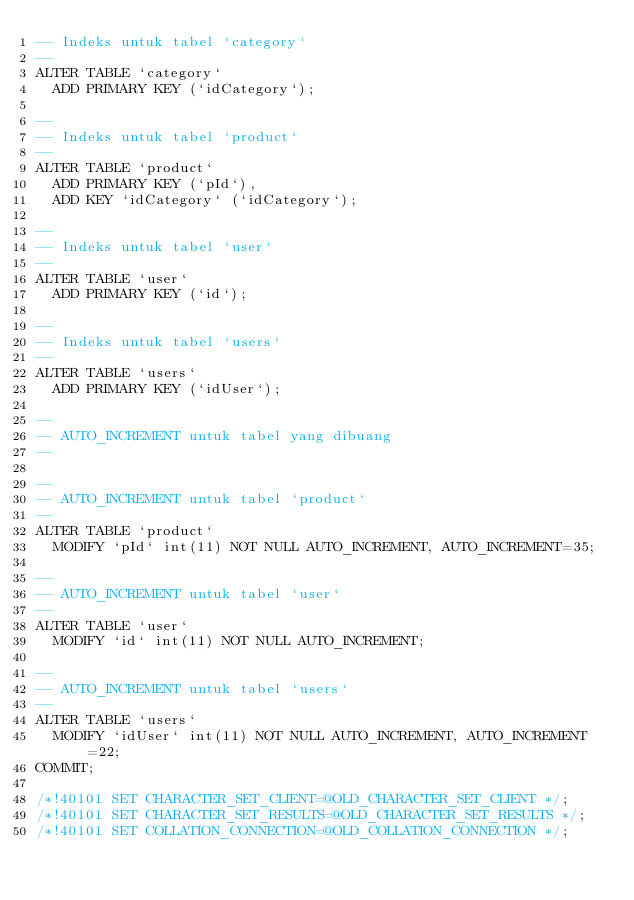Convert code to text. <code><loc_0><loc_0><loc_500><loc_500><_SQL_>-- Indeks untuk tabel `category`
--
ALTER TABLE `category`
  ADD PRIMARY KEY (`idCategory`);

--
-- Indeks untuk tabel `product`
--
ALTER TABLE `product`
  ADD PRIMARY KEY (`pId`),
  ADD KEY `idCategory` (`idCategory`);

--
-- Indeks untuk tabel `user`
--
ALTER TABLE `user`
  ADD PRIMARY KEY (`id`);

--
-- Indeks untuk tabel `users`
--
ALTER TABLE `users`
  ADD PRIMARY KEY (`idUser`);

--
-- AUTO_INCREMENT untuk tabel yang dibuang
--

--
-- AUTO_INCREMENT untuk tabel `product`
--
ALTER TABLE `product`
  MODIFY `pId` int(11) NOT NULL AUTO_INCREMENT, AUTO_INCREMENT=35;

--
-- AUTO_INCREMENT untuk tabel `user`
--
ALTER TABLE `user`
  MODIFY `id` int(11) NOT NULL AUTO_INCREMENT;

--
-- AUTO_INCREMENT untuk tabel `users`
--
ALTER TABLE `users`
  MODIFY `idUser` int(11) NOT NULL AUTO_INCREMENT, AUTO_INCREMENT=22;
COMMIT;

/*!40101 SET CHARACTER_SET_CLIENT=@OLD_CHARACTER_SET_CLIENT */;
/*!40101 SET CHARACTER_SET_RESULTS=@OLD_CHARACTER_SET_RESULTS */;
/*!40101 SET COLLATION_CONNECTION=@OLD_COLLATION_CONNECTION */;
</code> 